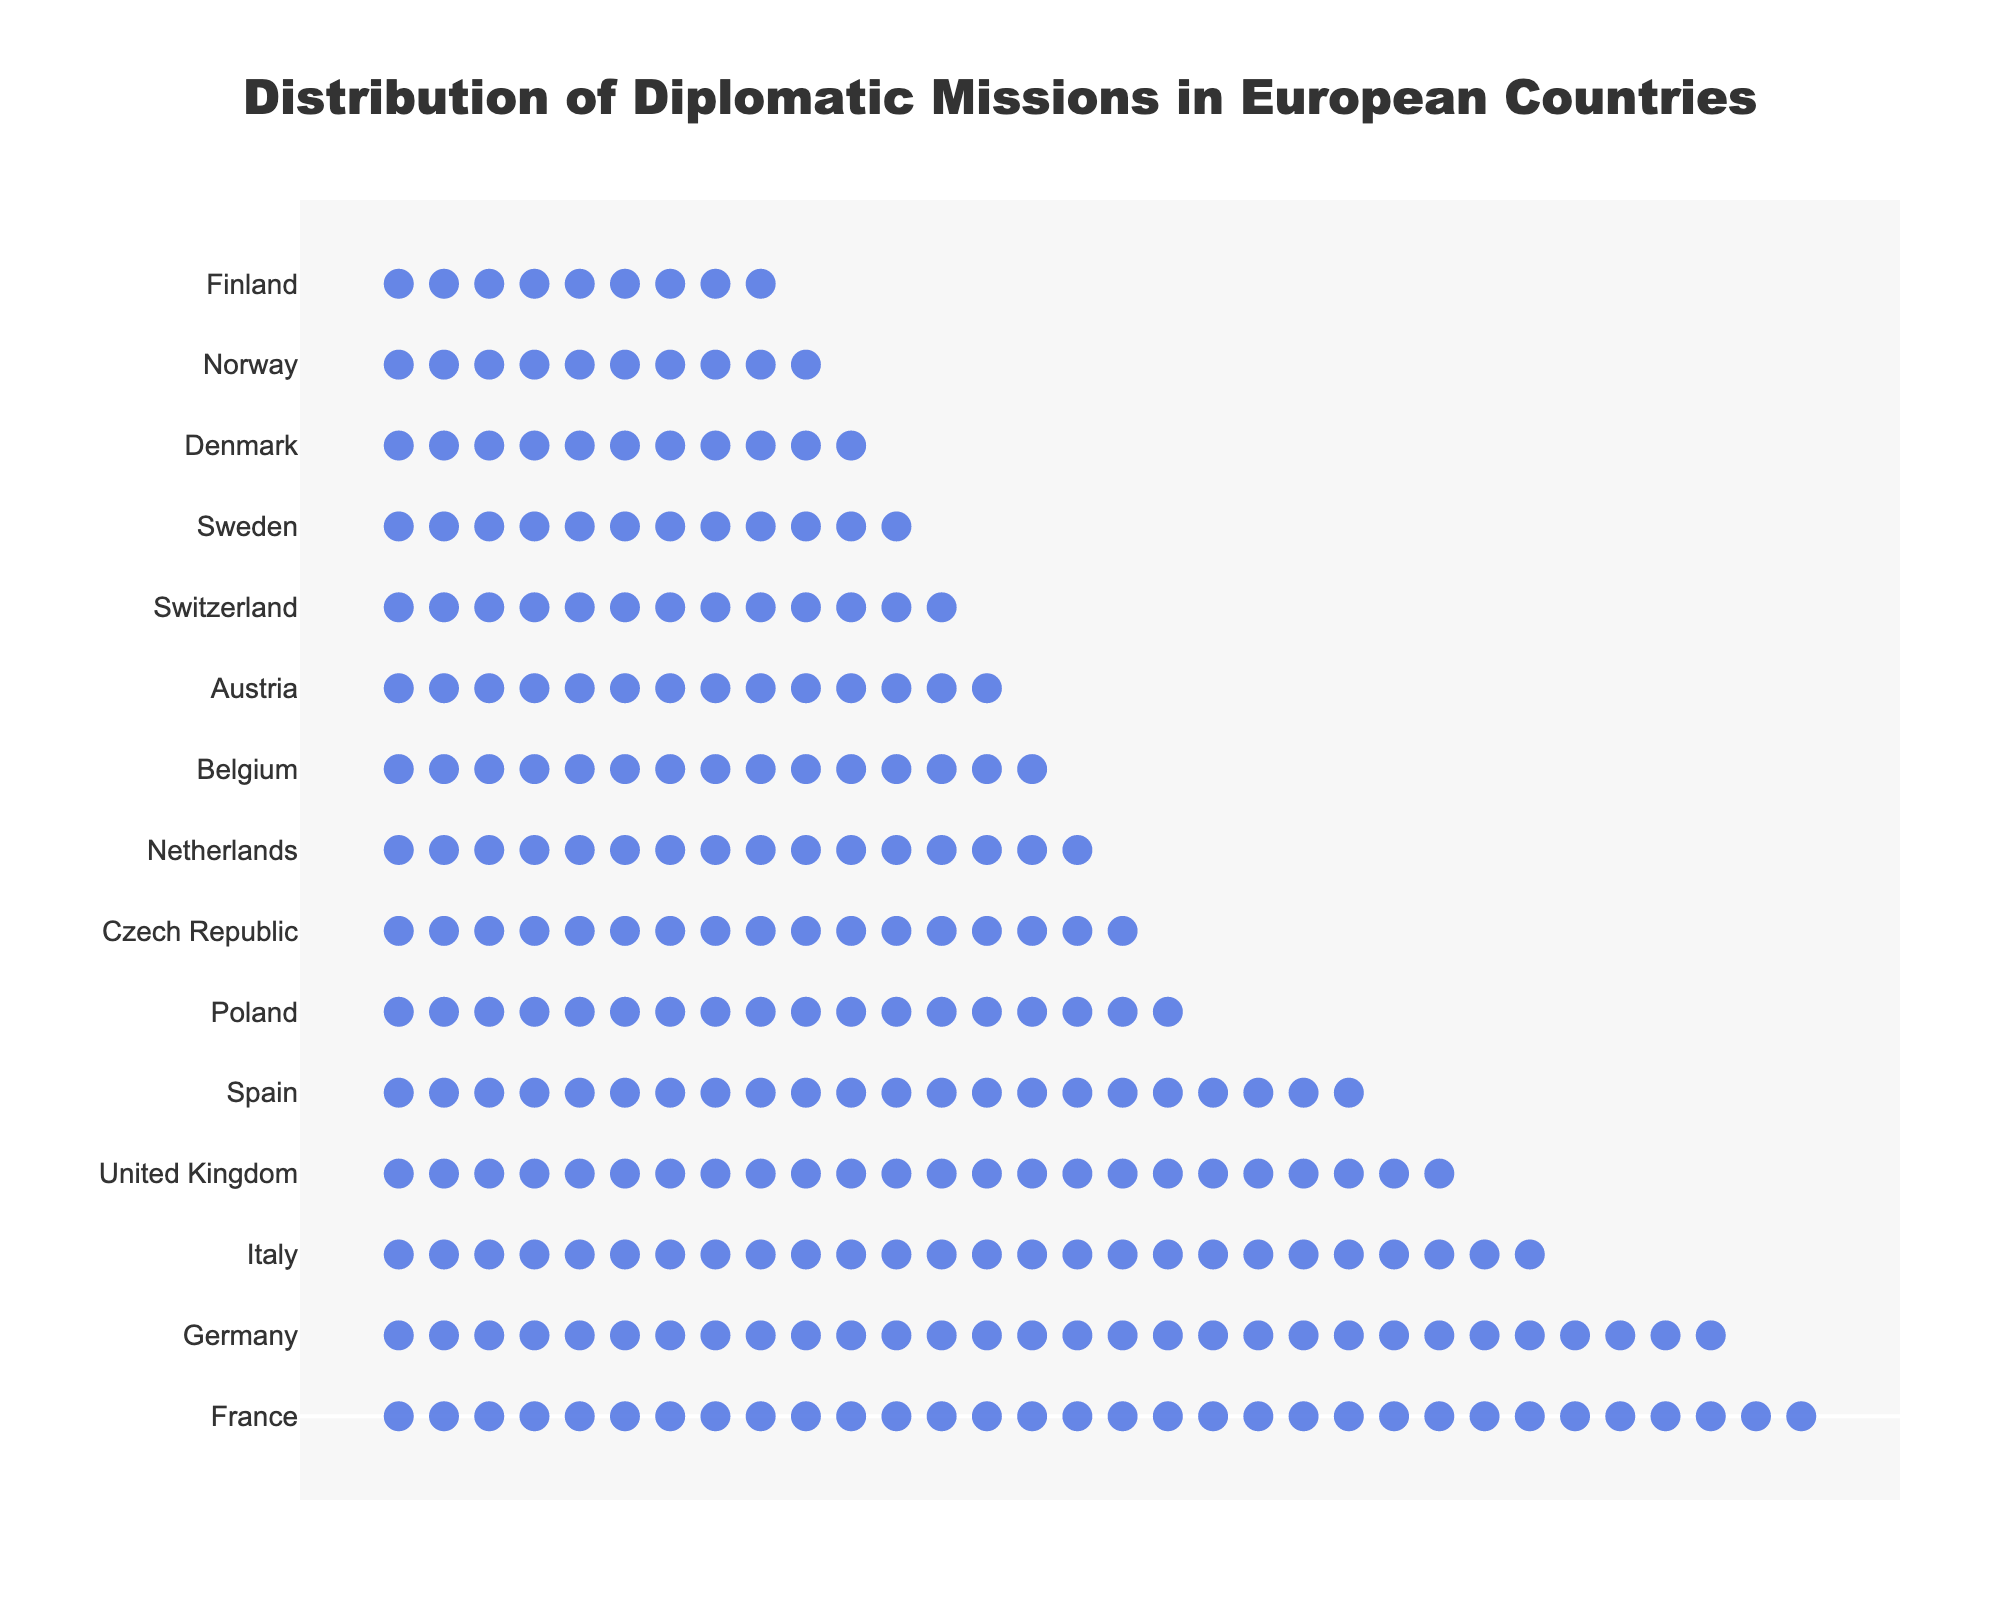what is the title of the plot? The title of the plot is positioned at the top center and typically in a larger font size, which reads 'Distribution of Diplomatic Missions in European Countries.'
Answer: 'Distribution of Diplomatic Missions in European Countries.' what do the circles in the plot represent? The annotation at the bottom of the plot explains that each circle icon represents 5 diplomatic missions.
Answer: 5 diplomatic missions Which country has the highest number of diplomatic missions? The country at the top of the y-axis, associated with the most circles horizontally, indicates the country with the highest number of diplomatic missions, which is France with 160.
Answer: France Which country ranks third in terms of the number of diplomatic missions? By counting from the top, the third country listed on the y-axis, each corresponding with its series of icon rows, is the United Kingdom, which has 120 diplomatic missions.
Answer: United Kingdom How many more diplomatic missions does Germany have compared to Poland? Germany has 150 diplomatic missions, and Poland has 90. The difference is calculated as 150 - 90 = 60.
Answer: 60 What is the total number of diplomatic missions in the top 5 countries combined? The top 5 countries are France, Germany, Italy, United Kingdom, and Spain. Their total is 160 + 150 + 130 + 120 + 110 = 670.
Answer: 670 How many countries have fewer than 100 diplomatic missions? By scanning countries from the 6th place downwards on the y-axis, we count Poland (90), Czech Republic (85), Netherlands (80), Belgium (75), Austria (70), Switzerland (65), Sweden (60), Denmark (55), Norway (50), and Finland (45), resulting in 10 countries.
Answer: 10 Which two countries have an equal number of diplomatic missions? By visually comparing the number of circle icons, no two countries have an exactly equal number of diplomatic missions in this dataset.
Answer: None How many icons would Italy have if each icon represented 10 missions instead of 5? Italy has 130 missions. If each icon represented 10 missions, the new number of icons would be 130 / 10 = 13.
Answer: 13 What is the average number of diplomatic missions among all listed countries? Sum the number of diplomatic missions for all 15 countries: 160 + 150 + 120 + 130 + 110 + 90 + 85 + 80 +75 + 70 + 65 + 60 + 55 + 50 + 45 = 1305. Divide by the number of countries (15). The average is 1305 / 15 = 87.
Answer: 87 